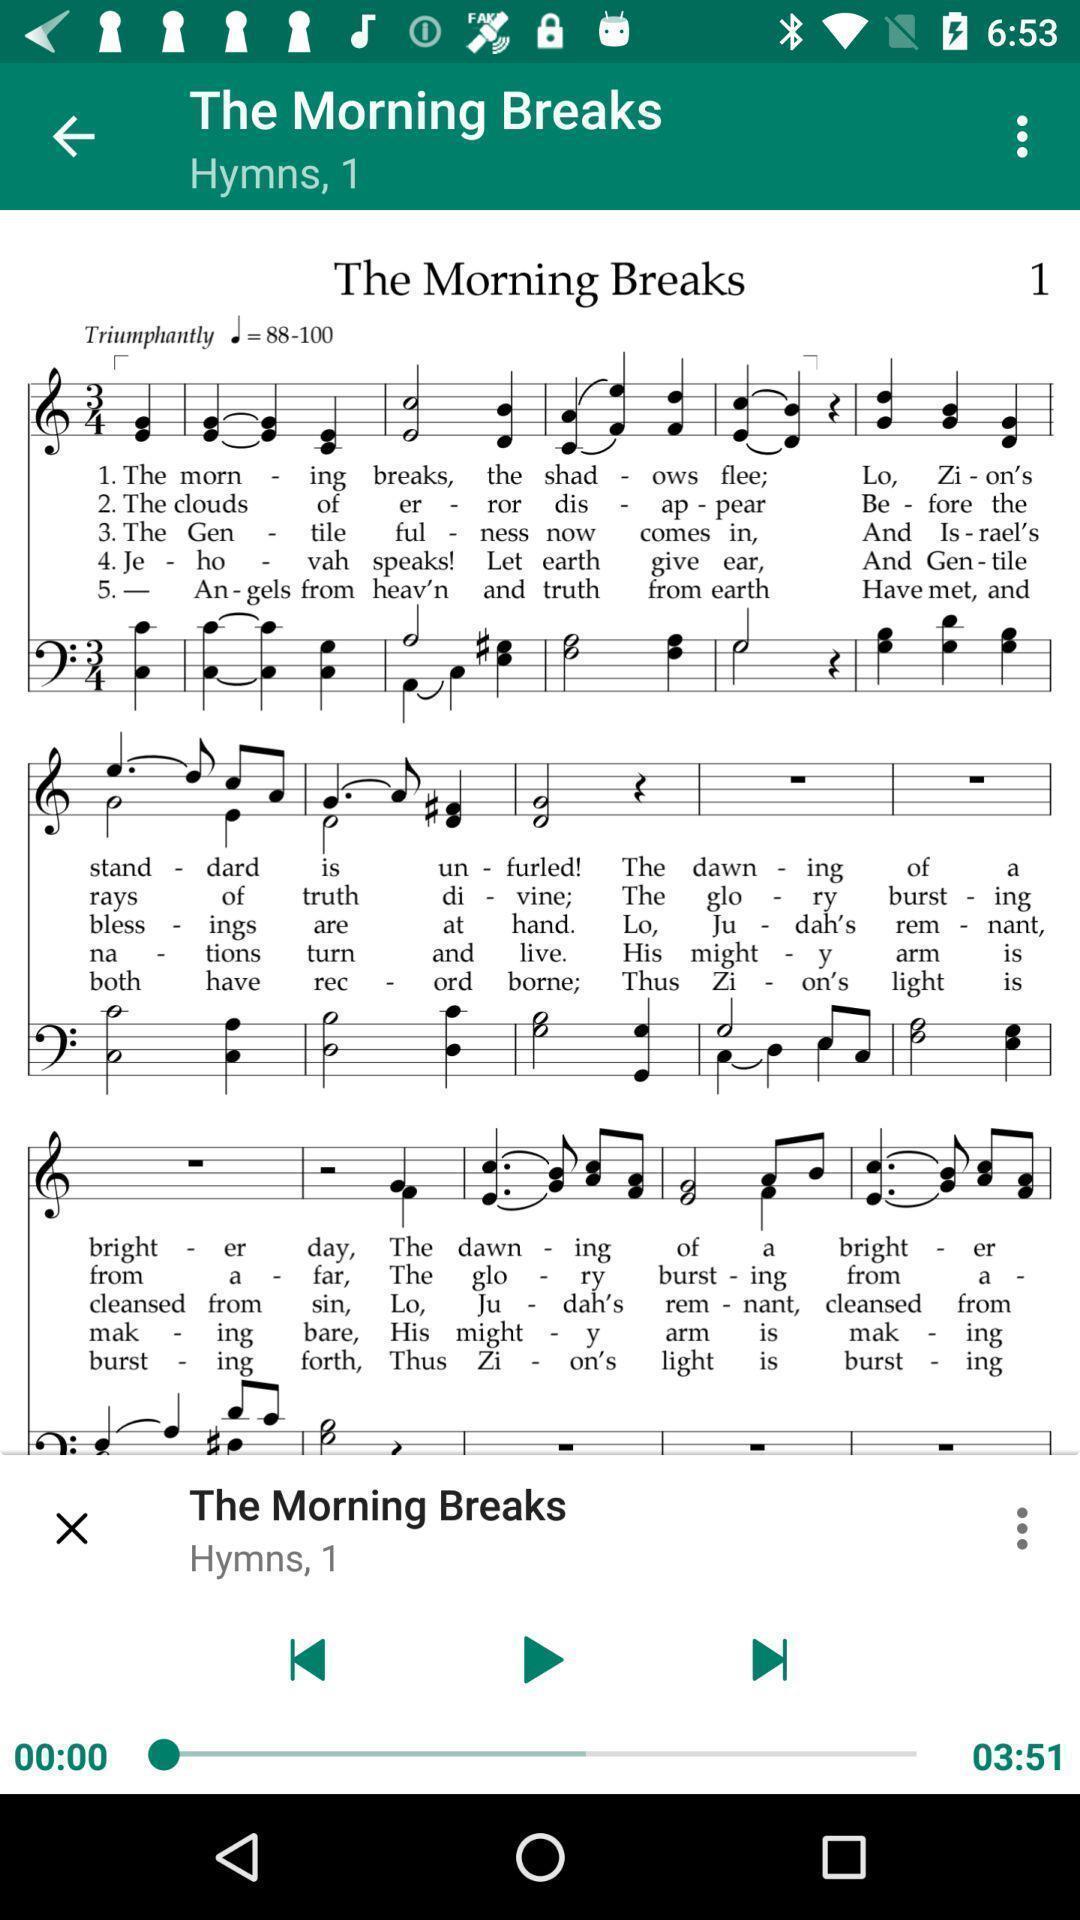Provide a textual representation of this image. Screen page of a music app. 